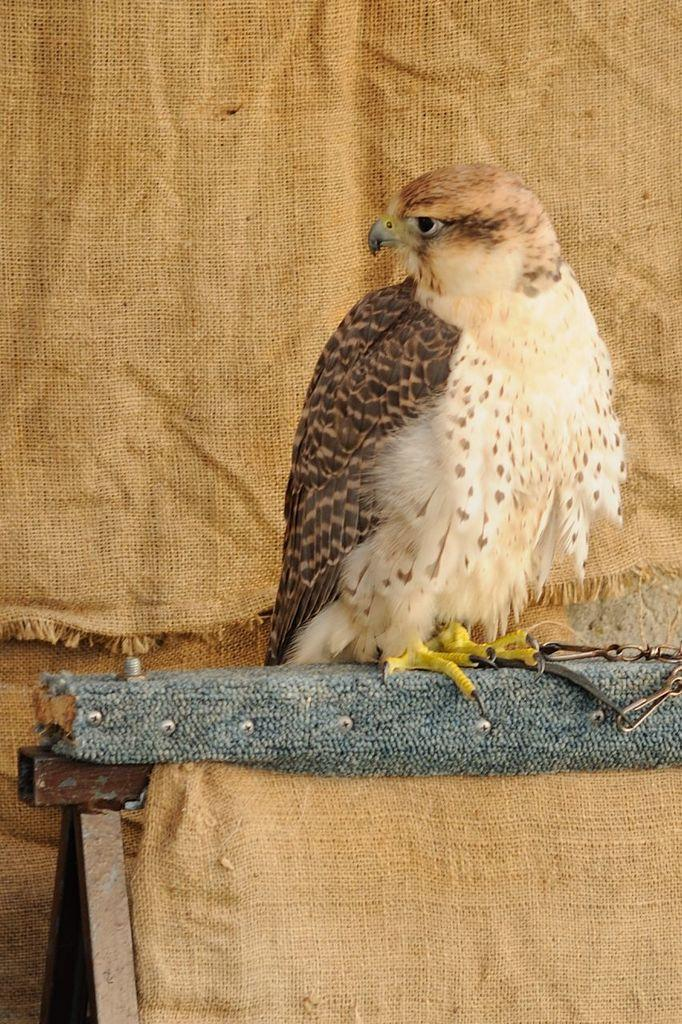What type of animal is in the image? There is a bird in the image. Where is the bird located? The bird is standing on a table. Can you describe the bird's coloring? The bird has brown and cream coloring. What can be seen in the background of the image? There is a rice bag fabric in the background of the image. What type of quartz is present in the image? There is no quartz present in the image; it features a bird standing on a table. What knowledge can be gained from the bird in the image? The image does not convey any specific knowledge or information about the bird. 